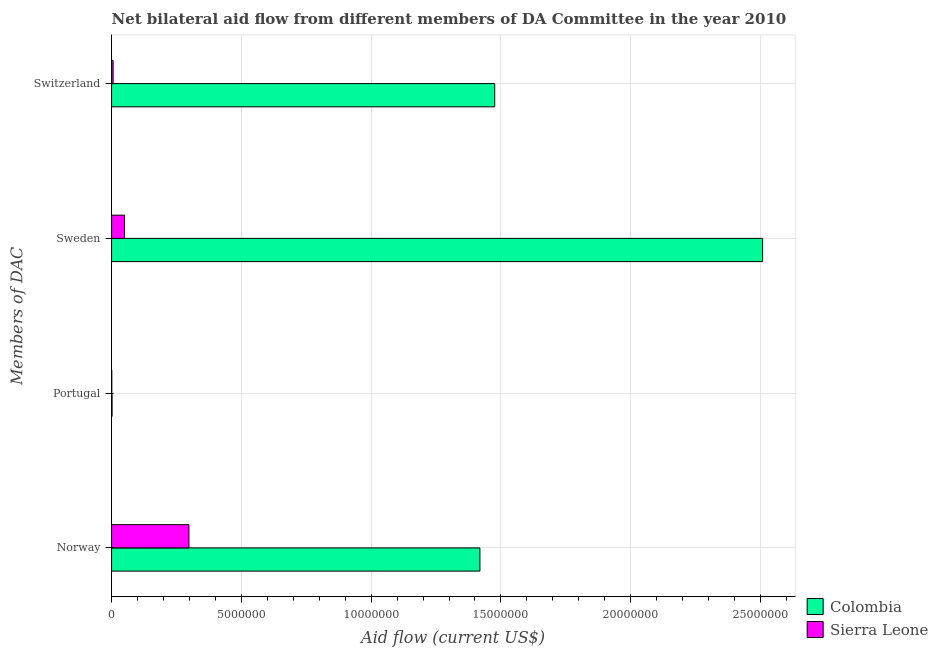How many different coloured bars are there?
Your response must be concise. 2. How many groups of bars are there?
Provide a succinct answer. 4. Are the number of bars per tick equal to the number of legend labels?
Your answer should be very brief. Yes. What is the amount of aid given by portugal in Colombia?
Offer a terse response. 2.00e+04. Across all countries, what is the maximum amount of aid given by portugal?
Ensure brevity in your answer.  2.00e+04. Across all countries, what is the minimum amount of aid given by norway?
Your answer should be very brief. 2.98e+06. In which country was the amount of aid given by switzerland maximum?
Your answer should be compact. Colombia. In which country was the amount of aid given by switzerland minimum?
Your answer should be very brief. Sierra Leone. What is the total amount of aid given by norway in the graph?
Your answer should be compact. 1.72e+07. What is the difference between the amount of aid given by switzerland in Colombia and that in Sierra Leone?
Offer a very short reply. 1.47e+07. What is the difference between the amount of aid given by norway in Sierra Leone and the amount of aid given by sweden in Colombia?
Keep it short and to the point. -2.21e+07. What is the average amount of aid given by portugal per country?
Offer a terse response. 1.50e+04. What is the difference between the amount of aid given by norway and amount of aid given by portugal in Colombia?
Your answer should be very brief. 1.42e+07. What is the ratio of the amount of aid given by norway in Colombia to that in Sierra Leone?
Make the answer very short. 4.76. Is the amount of aid given by norway in Sierra Leone less than that in Colombia?
Provide a short and direct response. Yes. Is the difference between the amount of aid given by portugal in Colombia and Sierra Leone greater than the difference between the amount of aid given by norway in Colombia and Sierra Leone?
Give a very brief answer. No. What is the difference between the highest and the second highest amount of aid given by portugal?
Provide a short and direct response. 10000. What is the difference between the highest and the lowest amount of aid given by sweden?
Offer a terse response. 2.46e+07. In how many countries, is the amount of aid given by portugal greater than the average amount of aid given by portugal taken over all countries?
Make the answer very short. 1. Is the sum of the amount of aid given by portugal in Colombia and Sierra Leone greater than the maximum amount of aid given by switzerland across all countries?
Provide a succinct answer. No. What does the 1st bar from the top in Portugal represents?
Keep it short and to the point. Sierra Leone. What does the 2nd bar from the bottom in Norway represents?
Ensure brevity in your answer.  Sierra Leone. Is it the case that in every country, the sum of the amount of aid given by norway and amount of aid given by portugal is greater than the amount of aid given by sweden?
Provide a succinct answer. No. Are all the bars in the graph horizontal?
Give a very brief answer. Yes. How many countries are there in the graph?
Provide a short and direct response. 2. Does the graph contain any zero values?
Your response must be concise. No. Does the graph contain grids?
Ensure brevity in your answer.  Yes. How many legend labels are there?
Give a very brief answer. 2. What is the title of the graph?
Your response must be concise. Net bilateral aid flow from different members of DA Committee in the year 2010. What is the label or title of the X-axis?
Make the answer very short. Aid flow (current US$). What is the label or title of the Y-axis?
Your response must be concise. Members of DAC. What is the Aid flow (current US$) in Colombia in Norway?
Offer a very short reply. 1.42e+07. What is the Aid flow (current US$) of Sierra Leone in Norway?
Ensure brevity in your answer.  2.98e+06. What is the Aid flow (current US$) in Colombia in Sweden?
Give a very brief answer. 2.51e+07. What is the Aid flow (current US$) in Colombia in Switzerland?
Keep it short and to the point. 1.48e+07. What is the Aid flow (current US$) in Sierra Leone in Switzerland?
Offer a very short reply. 6.00e+04. Across all Members of DAC, what is the maximum Aid flow (current US$) in Colombia?
Your response must be concise. 2.51e+07. Across all Members of DAC, what is the maximum Aid flow (current US$) of Sierra Leone?
Offer a terse response. 2.98e+06. Across all Members of DAC, what is the minimum Aid flow (current US$) of Colombia?
Your answer should be very brief. 2.00e+04. What is the total Aid flow (current US$) in Colombia in the graph?
Give a very brief answer. 5.40e+07. What is the total Aid flow (current US$) in Sierra Leone in the graph?
Ensure brevity in your answer.  3.55e+06. What is the difference between the Aid flow (current US$) in Colombia in Norway and that in Portugal?
Ensure brevity in your answer.  1.42e+07. What is the difference between the Aid flow (current US$) in Sierra Leone in Norway and that in Portugal?
Your answer should be very brief. 2.97e+06. What is the difference between the Aid flow (current US$) in Colombia in Norway and that in Sweden?
Ensure brevity in your answer.  -1.09e+07. What is the difference between the Aid flow (current US$) of Sierra Leone in Norway and that in Sweden?
Your answer should be very brief. 2.48e+06. What is the difference between the Aid flow (current US$) in Colombia in Norway and that in Switzerland?
Your answer should be very brief. -5.70e+05. What is the difference between the Aid flow (current US$) in Sierra Leone in Norway and that in Switzerland?
Ensure brevity in your answer.  2.92e+06. What is the difference between the Aid flow (current US$) of Colombia in Portugal and that in Sweden?
Offer a very short reply. -2.51e+07. What is the difference between the Aid flow (current US$) of Sierra Leone in Portugal and that in Sweden?
Your answer should be compact. -4.90e+05. What is the difference between the Aid flow (current US$) of Colombia in Portugal and that in Switzerland?
Ensure brevity in your answer.  -1.47e+07. What is the difference between the Aid flow (current US$) of Colombia in Sweden and that in Switzerland?
Offer a very short reply. 1.03e+07. What is the difference between the Aid flow (current US$) in Sierra Leone in Sweden and that in Switzerland?
Ensure brevity in your answer.  4.40e+05. What is the difference between the Aid flow (current US$) of Colombia in Norway and the Aid flow (current US$) of Sierra Leone in Portugal?
Your answer should be compact. 1.42e+07. What is the difference between the Aid flow (current US$) in Colombia in Norway and the Aid flow (current US$) in Sierra Leone in Sweden?
Your response must be concise. 1.37e+07. What is the difference between the Aid flow (current US$) in Colombia in Norway and the Aid flow (current US$) in Sierra Leone in Switzerland?
Your answer should be very brief. 1.41e+07. What is the difference between the Aid flow (current US$) in Colombia in Portugal and the Aid flow (current US$) in Sierra Leone in Sweden?
Your answer should be compact. -4.80e+05. What is the difference between the Aid flow (current US$) of Colombia in Portugal and the Aid flow (current US$) of Sierra Leone in Switzerland?
Offer a very short reply. -4.00e+04. What is the difference between the Aid flow (current US$) in Colombia in Sweden and the Aid flow (current US$) in Sierra Leone in Switzerland?
Your answer should be very brief. 2.50e+07. What is the average Aid flow (current US$) of Colombia per Members of DAC?
Offer a very short reply. 1.35e+07. What is the average Aid flow (current US$) of Sierra Leone per Members of DAC?
Give a very brief answer. 8.88e+05. What is the difference between the Aid flow (current US$) of Colombia and Aid flow (current US$) of Sierra Leone in Norway?
Offer a very short reply. 1.12e+07. What is the difference between the Aid flow (current US$) in Colombia and Aid flow (current US$) in Sierra Leone in Portugal?
Offer a terse response. 10000. What is the difference between the Aid flow (current US$) of Colombia and Aid flow (current US$) of Sierra Leone in Sweden?
Keep it short and to the point. 2.46e+07. What is the difference between the Aid flow (current US$) in Colombia and Aid flow (current US$) in Sierra Leone in Switzerland?
Ensure brevity in your answer.  1.47e+07. What is the ratio of the Aid flow (current US$) in Colombia in Norway to that in Portugal?
Make the answer very short. 709.5. What is the ratio of the Aid flow (current US$) in Sierra Leone in Norway to that in Portugal?
Offer a very short reply. 298. What is the ratio of the Aid flow (current US$) in Colombia in Norway to that in Sweden?
Keep it short and to the point. 0.57. What is the ratio of the Aid flow (current US$) in Sierra Leone in Norway to that in Sweden?
Keep it short and to the point. 5.96. What is the ratio of the Aid flow (current US$) in Colombia in Norway to that in Switzerland?
Give a very brief answer. 0.96. What is the ratio of the Aid flow (current US$) in Sierra Leone in Norway to that in Switzerland?
Provide a succinct answer. 49.67. What is the ratio of the Aid flow (current US$) of Colombia in Portugal to that in Sweden?
Ensure brevity in your answer.  0. What is the ratio of the Aid flow (current US$) of Colombia in Portugal to that in Switzerland?
Make the answer very short. 0. What is the ratio of the Aid flow (current US$) in Sierra Leone in Portugal to that in Switzerland?
Keep it short and to the point. 0.17. What is the ratio of the Aid flow (current US$) in Colombia in Sweden to that in Switzerland?
Your response must be concise. 1.7. What is the ratio of the Aid flow (current US$) in Sierra Leone in Sweden to that in Switzerland?
Give a very brief answer. 8.33. What is the difference between the highest and the second highest Aid flow (current US$) in Colombia?
Ensure brevity in your answer.  1.03e+07. What is the difference between the highest and the second highest Aid flow (current US$) in Sierra Leone?
Offer a very short reply. 2.48e+06. What is the difference between the highest and the lowest Aid flow (current US$) in Colombia?
Make the answer very short. 2.51e+07. What is the difference between the highest and the lowest Aid flow (current US$) of Sierra Leone?
Offer a very short reply. 2.97e+06. 